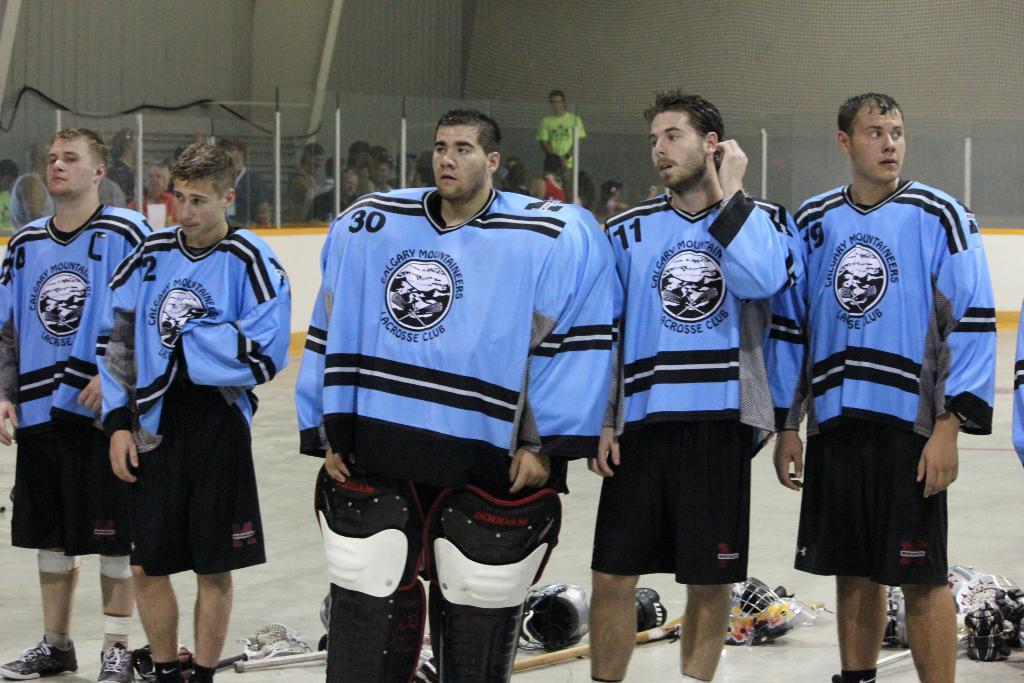Provide a one-sentence caption for the provided image. Six Calgary Mountaineers Lacrosse Club players in baby blue and black jerseys stand side by side. 